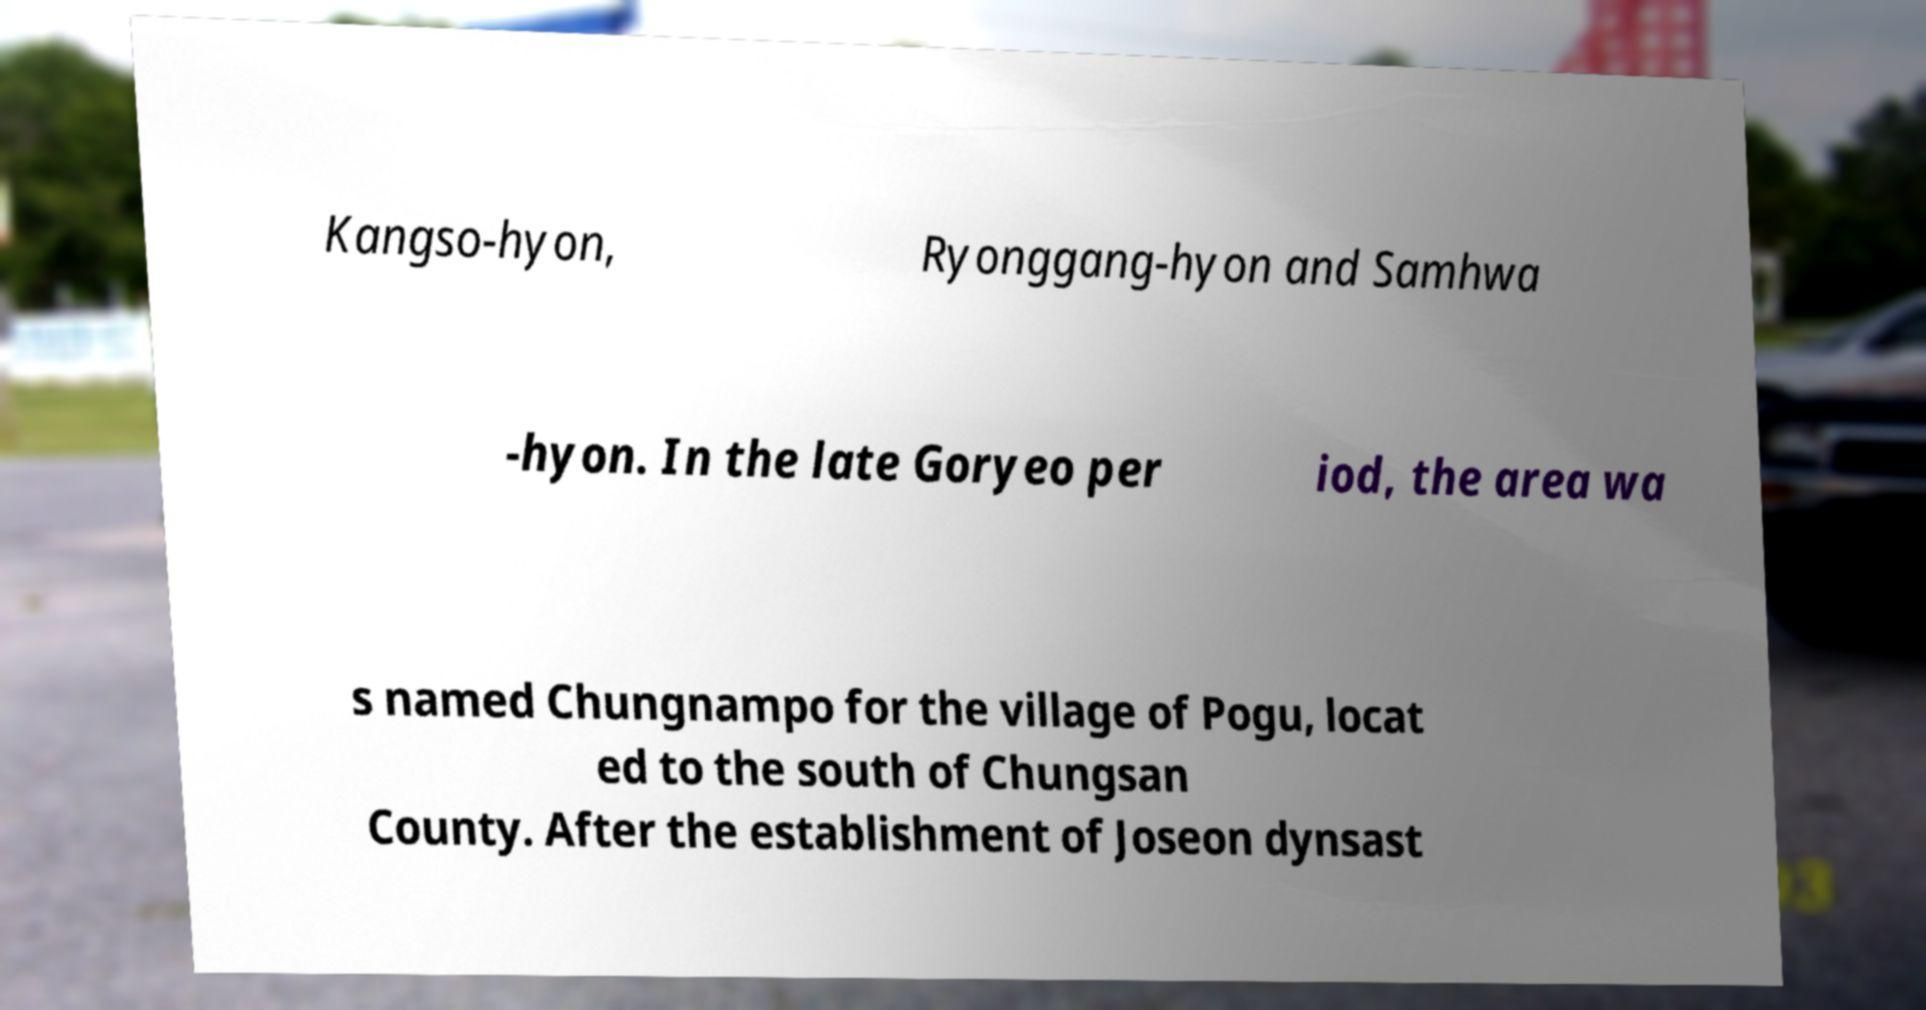Could you assist in decoding the text presented in this image and type it out clearly? Kangso-hyon, Ryonggang-hyon and Samhwa -hyon. In the late Goryeo per iod, the area wa s named Chungnampo for the village of Pogu, locat ed to the south of Chungsan County. After the establishment of Joseon dynsast 